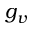Convert formula to latex. <formula><loc_0><loc_0><loc_500><loc_500>g _ { v }</formula> 